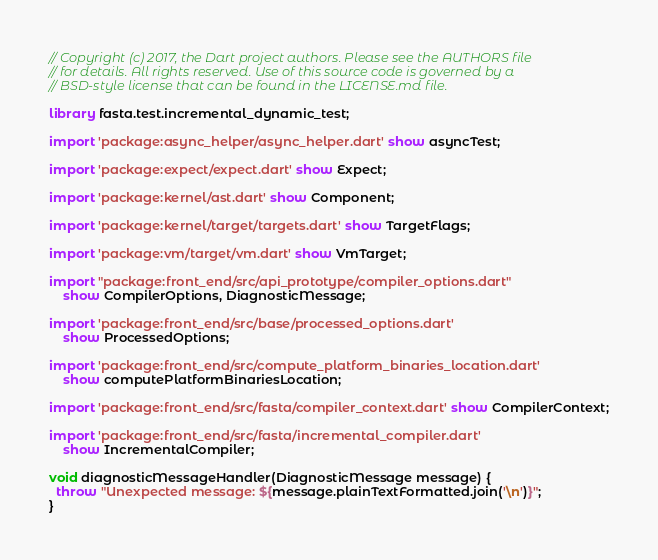<code> <loc_0><loc_0><loc_500><loc_500><_Dart_>// Copyright (c) 2017, the Dart project authors. Please see the AUTHORS file
// for details. All rights reserved. Use of this source code is governed by a
// BSD-style license that can be found in the LICENSE.md file.

library fasta.test.incremental_dynamic_test;

import 'package:async_helper/async_helper.dart' show asyncTest;

import 'package:expect/expect.dart' show Expect;

import 'package:kernel/ast.dart' show Component;

import 'package:kernel/target/targets.dart' show TargetFlags;

import 'package:vm/target/vm.dart' show VmTarget;

import "package:front_end/src/api_prototype/compiler_options.dart"
    show CompilerOptions, DiagnosticMessage;

import 'package:front_end/src/base/processed_options.dart'
    show ProcessedOptions;

import 'package:front_end/src/compute_platform_binaries_location.dart'
    show computePlatformBinariesLocation;

import 'package:front_end/src/fasta/compiler_context.dart' show CompilerContext;

import 'package:front_end/src/fasta/incremental_compiler.dart'
    show IncrementalCompiler;

void diagnosticMessageHandler(DiagnosticMessage message) {
  throw "Unexpected message: ${message.plainTextFormatted.join('\n')}";
}
</code> 